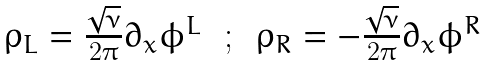<formula> <loc_0><loc_0><loc_500><loc_500>\begin{array} { c c c } \rho _ { L } = \frac { \sqrt { \nu } } { 2 \pi } \partial _ { x } \phi ^ { L } & \, ; \, & \rho _ { R } = - \frac { \sqrt { \nu } } { 2 \pi } \partial _ { x } \phi ^ { R } \end{array}</formula> 